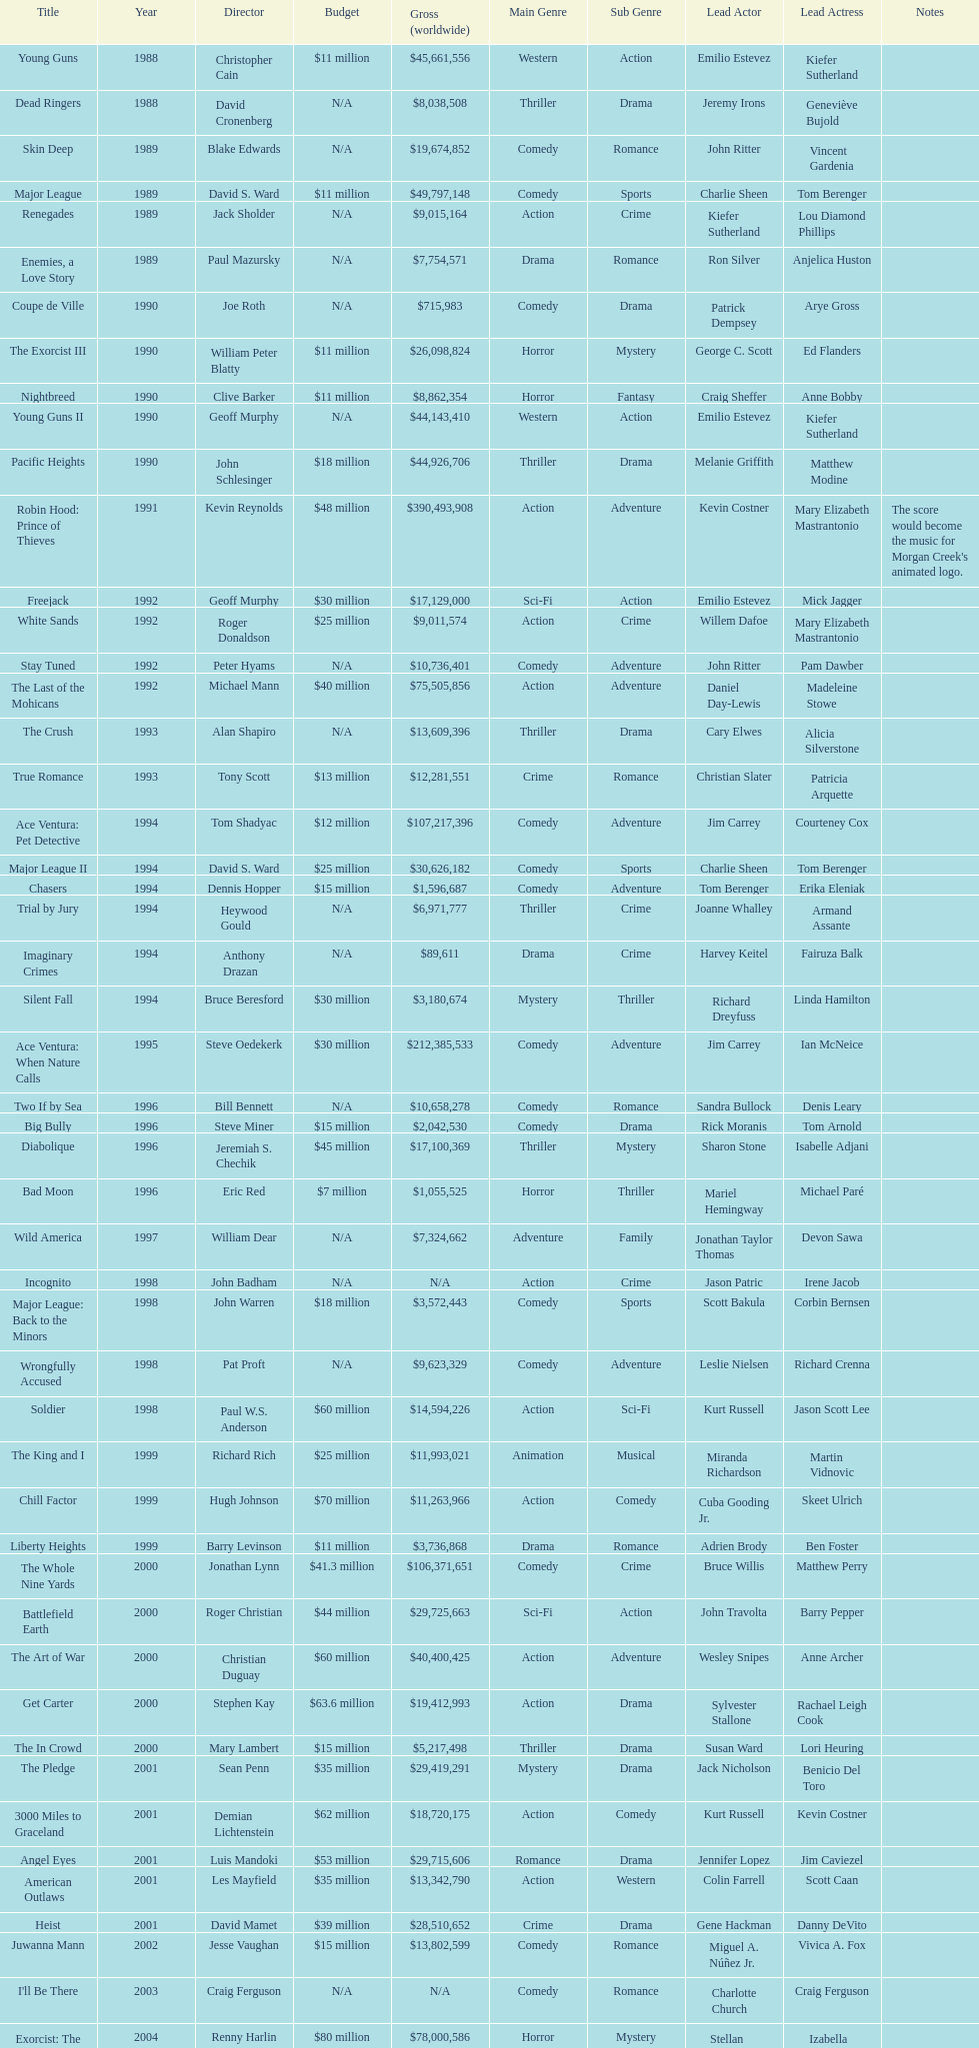Which film had a higher budget, ace ventura: when nature calls, or major league: back to the minors? Ace Ventura: When Nature Calls. 